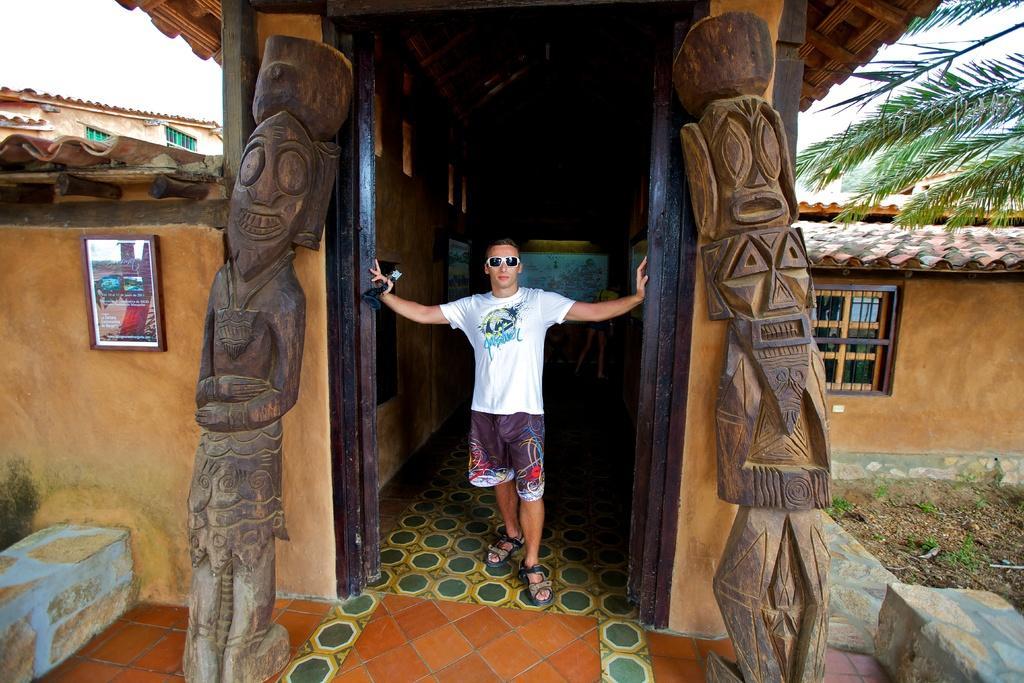In one or two sentences, can you explain what this image depicts? This image is taken outdoors. At the bottom of the image there is a floor. In the middle of the image there is a house with walls, windows, a door and roofs. There are two pillars with carvings and a man is standing on the floor. There is a picture frame on the wall. On the right side of the image there is a tree. At the top left of the image there is the sky. 